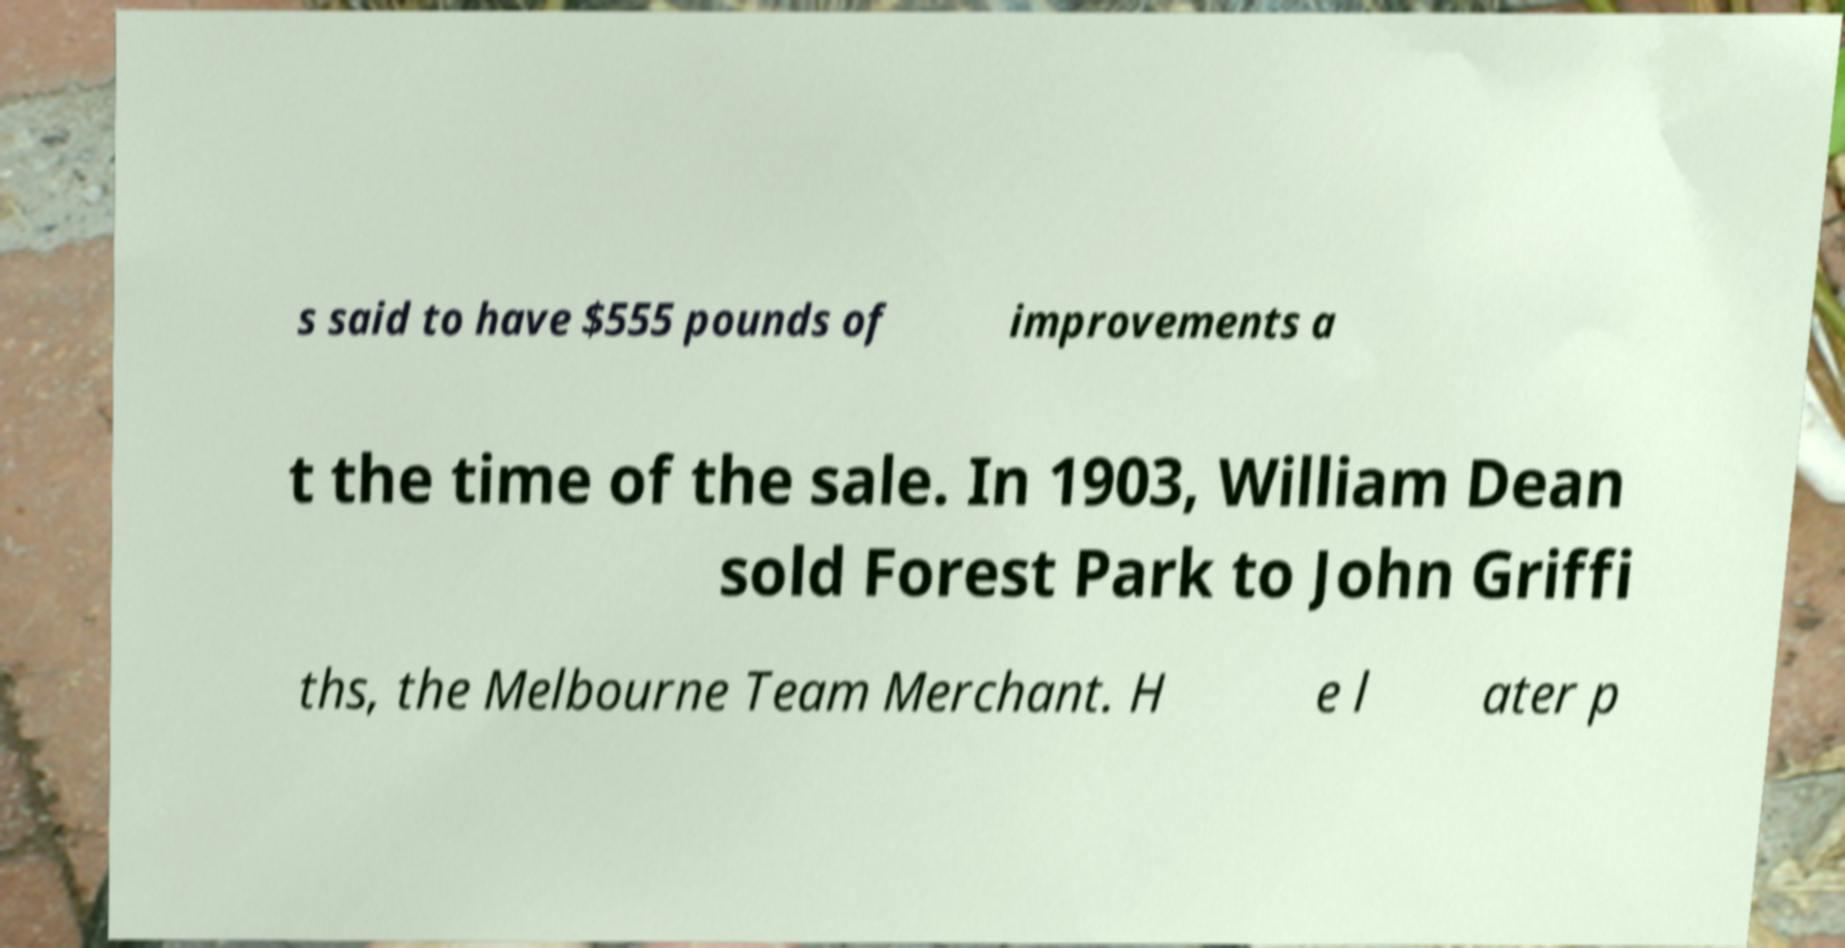What messages or text are displayed in this image? I need them in a readable, typed format. s said to have $555 pounds of improvements a t the time of the sale. In 1903, William Dean sold Forest Park to John Griffi ths, the Melbourne Team Merchant. H e l ater p 